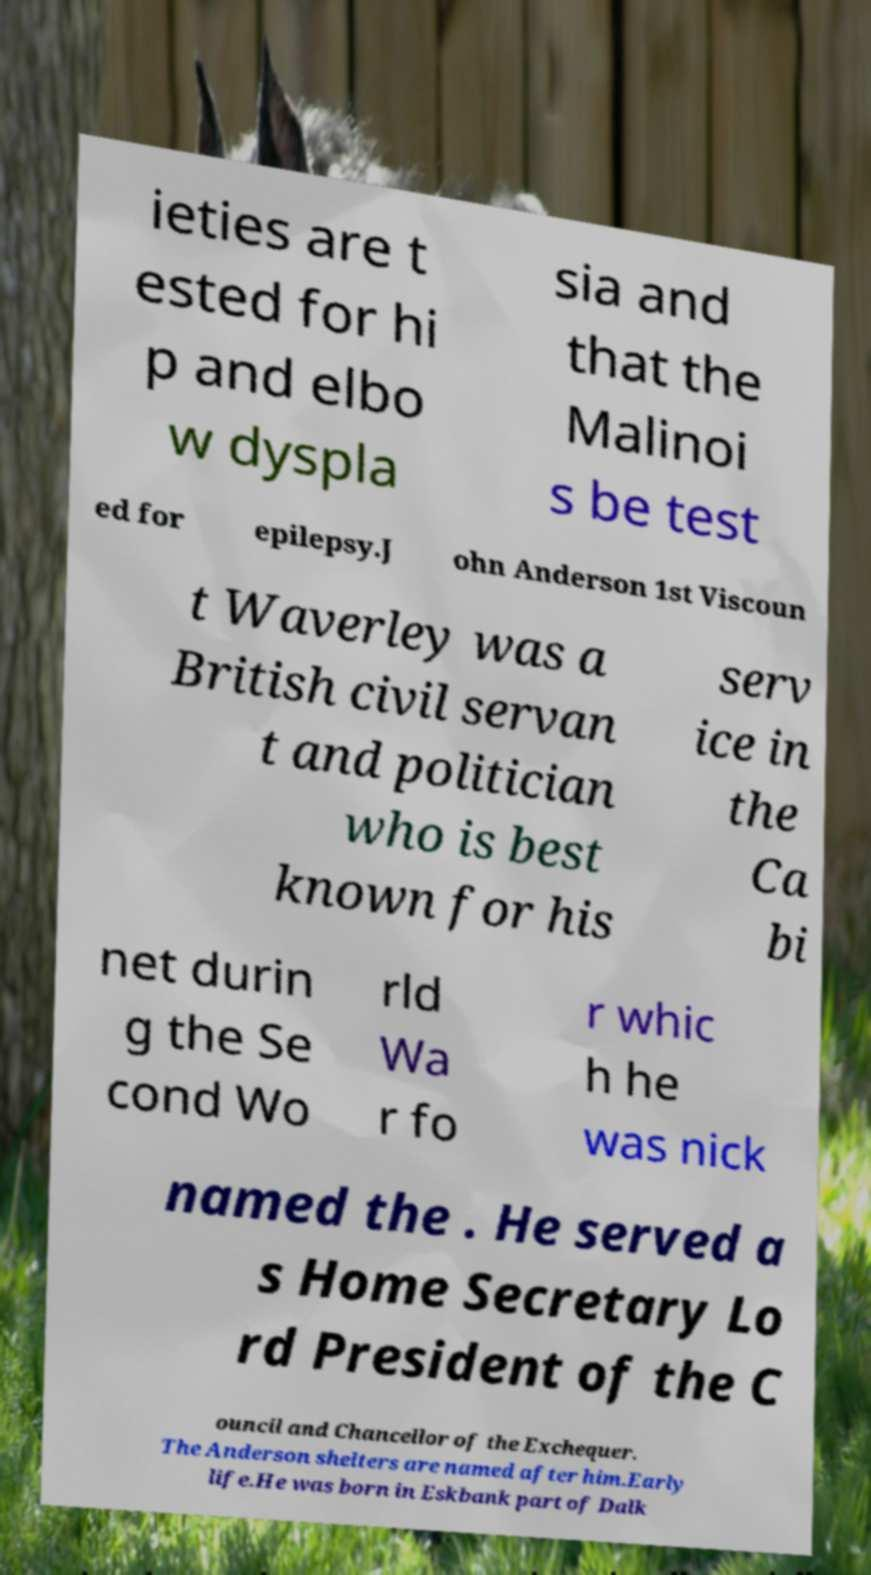Please read and relay the text visible in this image. What does it say? ieties are t ested for hi p and elbo w dyspla sia and that the Malinoi s be test ed for epilepsy.J ohn Anderson 1st Viscoun t Waverley was a British civil servan t and politician who is best known for his serv ice in the Ca bi net durin g the Se cond Wo rld Wa r fo r whic h he was nick named the . He served a s Home Secretary Lo rd President of the C ouncil and Chancellor of the Exchequer. The Anderson shelters are named after him.Early life.He was born in Eskbank part of Dalk 